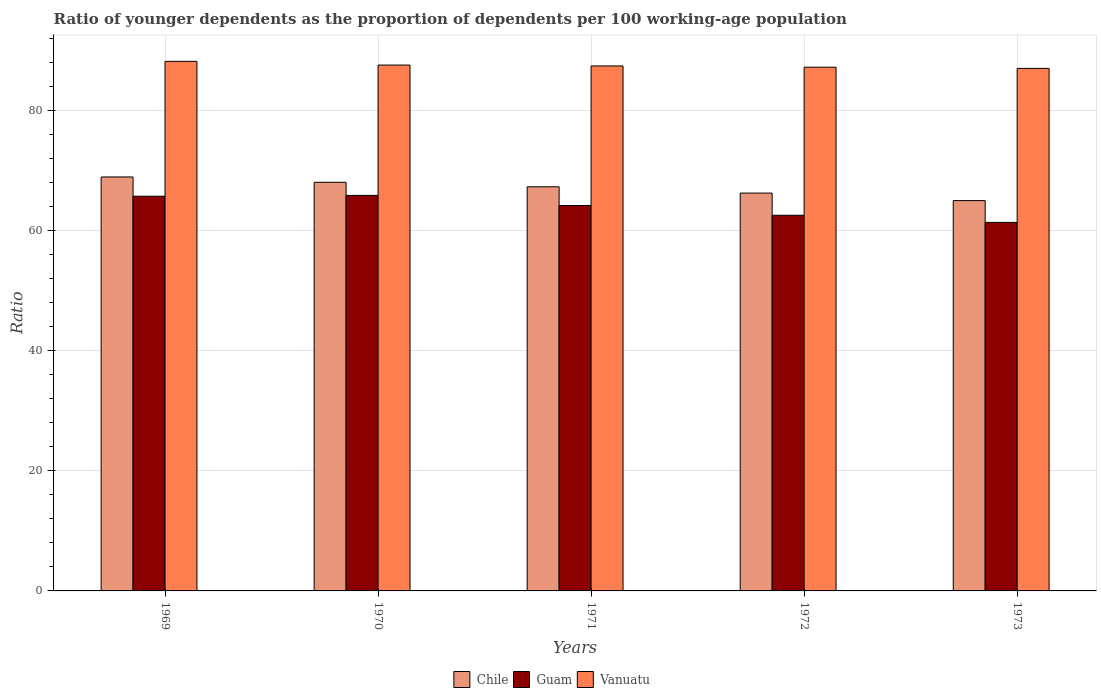How many groups of bars are there?
Ensure brevity in your answer.  5. How many bars are there on the 5th tick from the left?
Your response must be concise. 3. How many bars are there on the 2nd tick from the right?
Make the answer very short. 3. What is the label of the 2nd group of bars from the left?
Offer a terse response. 1970. In how many cases, is the number of bars for a given year not equal to the number of legend labels?
Provide a succinct answer. 0. What is the age dependency ratio(young) in Vanuatu in 1972?
Offer a terse response. 87.15. Across all years, what is the maximum age dependency ratio(young) in Guam?
Your answer should be compact. 65.81. Across all years, what is the minimum age dependency ratio(young) in Guam?
Provide a short and direct response. 61.32. In which year was the age dependency ratio(young) in Guam maximum?
Keep it short and to the point. 1970. What is the total age dependency ratio(young) in Guam in the graph?
Offer a very short reply. 319.45. What is the difference between the age dependency ratio(young) in Vanuatu in 1970 and that in 1972?
Offer a terse response. 0.35. What is the difference between the age dependency ratio(young) in Guam in 1969 and the age dependency ratio(young) in Vanuatu in 1972?
Ensure brevity in your answer.  -21.47. What is the average age dependency ratio(young) in Vanuatu per year?
Offer a terse response. 87.41. In the year 1973, what is the difference between the age dependency ratio(young) in Guam and age dependency ratio(young) in Chile?
Provide a short and direct response. -3.63. What is the ratio of the age dependency ratio(young) in Vanuatu in 1969 to that in 1972?
Keep it short and to the point. 1.01. Is the age dependency ratio(young) in Chile in 1970 less than that in 1972?
Offer a terse response. No. Is the difference between the age dependency ratio(young) in Guam in 1969 and 1971 greater than the difference between the age dependency ratio(young) in Chile in 1969 and 1971?
Provide a short and direct response. No. What is the difference between the highest and the second highest age dependency ratio(young) in Vanuatu?
Your answer should be very brief. 0.62. What is the difference between the highest and the lowest age dependency ratio(young) in Chile?
Offer a very short reply. 3.93. In how many years, is the age dependency ratio(young) in Vanuatu greater than the average age dependency ratio(young) in Vanuatu taken over all years?
Give a very brief answer. 2. Is the sum of the age dependency ratio(young) in Chile in 1970 and 1973 greater than the maximum age dependency ratio(young) in Vanuatu across all years?
Offer a terse response. Yes. What does the 3rd bar from the left in 1970 represents?
Your response must be concise. Vanuatu. What does the 1st bar from the right in 1971 represents?
Your response must be concise. Vanuatu. Is it the case that in every year, the sum of the age dependency ratio(young) in Chile and age dependency ratio(young) in Guam is greater than the age dependency ratio(young) in Vanuatu?
Offer a very short reply. Yes. How many bars are there?
Provide a succinct answer. 15. Are all the bars in the graph horizontal?
Your answer should be very brief. No. How many years are there in the graph?
Offer a terse response. 5. What is the difference between two consecutive major ticks on the Y-axis?
Your response must be concise. 20. Are the values on the major ticks of Y-axis written in scientific E-notation?
Keep it short and to the point. No. Does the graph contain any zero values?
Offer a very short reply. No. Where does the legend appear in the graph?
Ensure brevity in your answer.  Bottom center. How many legend labels are there?
Your answer should be compact. 3. How are the legend labels stacked?
Make the answer very short. Horizontal. What is the title of the graph?
Your response must be concise. Ratio of younger dependents as the proportion of dependents per 100 working-age population. Does "Guinea" appear as one of the legend labels in the graph?
Your response must be concise. No. What is the label or title of the X-axis?
Offer a terse response. Years. What is the label or title of the Y-axis?
Keep it short and to the point. Ratio. What is the Ratio of Chile in 1969?
Provide a short and direct response. 68.88. What is the Ratio of Guam in 1969?
Your response must be concise. 65.68. What is the Ratio of Vanuatu in 1969?
Make the answer very short. 88.12. What is the Ratio of Chile in 1970?
Your response must be concise. 67.99. What is the Ratio in Guam in 1970?
Provide a succinct answer. 65.81. What is the Ratio of Vanuatu in 1970?
Your response must be concise. 87.5. What is the Ratio of Chile in 1971?
Ensure brevity in your answer.  67.25. What is the Ratio of Guam in 1971?
Ensure brevity in your answer.  64.13. What is the Ratio in Vanuatu in 1971?
Your answer should be compact. 87.35. What is the Ratio of Chile in 1972?
Make the answer very short. 66.2. What is the Ratio of Guam in 1972?
Offer a very short reply. 62.51. What is the Ratio in Vanuatu in 1972?
Make the answer very short. 87.15. What is the Ratio of Chile in 1973?
Offer a terse response. 64.95. What is the Ratio of Guam in 1973?
Give a very brief answer. 61.32. What is the Ratio of Vanuatu in 1973?
Your response must be concise. 86.95. Across all years, what is the maximum Ratio of Chile?
Your answer should be very brief. 68.88. Across all years, what is the maximum Ratio of Guam?
Offer a very short reply. 65.81. Across all years, what is the maximum Ratio in Vanuatu?
Ensure brevity in your answer.  88.12. Across all years, what is the minimum Ratio of Chile?
Your answer should be compact. 64.95. Across all years, what is the minimum Ratio in Guam?
Provide a succinct answer. 61.32. Across all years, what is the minimum Ratio in Vanuatu?
Provide a short and direct response. 86.95. What is the total Ratio of Chile in the graph?
Provide a short and direct response. 335.26. What is the total Ratio in Guam in the graph?
Provide a short and direct response. 319.45. What is the total Ratio in Vanuatu in the graph?
Ensure brevity in your answer.  437.06. What is the difference between the Ratio in Chile in 1969 and that in 1970?
Keep it short and to the point. 0.89. What is the difference between the Ratio in Guam in 1969 and that in 1970?
Make the answer very short. -0.14. What is the difference between the Ratio in Vanuatu in 1969 and that in 1970?
Your response must be concise. 0.62. What is the difference between the Ratio of Chile in 1969 and that in 1971?
Offer a very short reply. 1.63. What is the difference between the Ratio of Guam in 1969 and that in 1971?
Keep it short and to the point. 1.55. What is the difference between the Ratio in Vanuatu in 1969 and that in 1971?
Ensure brevity in your answer.  0.76. What is the difference between the Ratio of Chile in 1969 and that in 1972?
Give a very brief answer. 2.68. What is the difference between the Ratio of Guam in 1969 and that in 1972?
Your answer should be compact. 3.17. What is the difference between the Ratio in Chile in 1969 and that in 1973?
Ensure brevity in your answer.  3.93. What is the difference between the Ratio in Guam in 1969 and that in 1973?
Your answer should be very brief. 4.36. What is the difference between the Ratio of Vanuatu in 1969 and that in 1973?
Your answer should be very brief. 1.17. What is the difference between the Ratio of Chile in 1970 and that in 1971?
Make the answer very short. 0.75. What is the difference between the Ratio of Guam in 1970 and that in 1971?
Offer a terse response. 1.68. What is the difference between the Ratio in Vanuatu in 1970 and that in 1971?
Provide a succinct answer. 0.14. What is the difference between the Ratio of Chile in 1970 and that in 1972?
Offer a terse response. 1.79. What is the difference between the Ratio in Guam in 1970 and that in 1972?
Provide a short and direct response. 3.31. What is the difference between the Ratio of Vanuatu in 1970 and that in 1972?
Offer a terse response. 0.35. What is the difference between the Ratio of Chile in 1970 and that in 1973?
Provide a short and direct response. 3.05. What is the difference between the Ratio in Guam in 1970 and that in 1973?
Provide a short and direct response. 4.5. What is the difference between the Ratio of Vanuatu in 1970 and that in 1973?
Provide a succinct answer. 0.55. What is the difference between the Ratio in Chile in 1971 and that in 1972?
Give a very brief answer. 1.05. What is the difference between the Ratio in Guam in 1971 and that in 1972?
Offer a terse response. 1.62. What is the difference between the Ratio in Vanuatu in 1971 and that in 1972?
Ensure brevity in your answer.  0.21. What is the difference between the Ratio in Chile in 1971 and that in 1973?
Your response must be concise. 2.3. What is the difference between the Ratio of Guam in 1971 and that in 1973?
Provide a succinct answer. 2.81. What is the difference between the Ratio of Vanuatu in 1971 and that in 1973?
Keep it short and to the point. 0.41. What is the difference between the Ratio in Chile in 1972 and that in 1973?
Your response must be concise. 1.25. What is the difference between the Ratio of Guam in 1972 and that in 1973?
Ensure brevity in your answer.  1.19. What is the difference between the Ratio of Vanuatu in 1972 and that in 1973?
Make the answer very short. 0.2. What is the difference between the Ratio of Chile in 1969 and the Ratio of Guam in 1970?
Provide a succinct answer. 3.07. What is the difference between the Ratio of Chile in 1969 and the Ratio of Vanuatu in 1970?
Provide a succinct answer. -18.62. What is the difference between the Ratio in Guam in 1969 and the Ratio in Vanuatu in 1970?
Provide a short and direct response. -21.82. What is the difference between the Ratio of Chile in 1969 and the Ratio of Guam in 1971?
Give a very brief answer. 4.75. What is the difference between the Ratio in Chile in 1969 and the Ratio in Vanuatu in 1971?
Your answer should be compact. -18.47. What is the difference between the Ratio of Guam in 1969 and the Ratio of Vanuatu in 1971?
Offer a very short reply. -21.68. What is the difference between the Ratio in Chile in 1969 and the Ratio in Guam in 1972?
Make the answer very short. 6.37. What is the difference between the Ratio in Chile in 1969 and the Ratio in Vanuatu in 1972?
Provide a short and direct response. -18.27. What is the difference between the Ratio of Guam in 1969 and the Ratio of Vanuatu in 1972?
Your response must be concise. -21.47. What is the difference between the Ratio in Chile in 1969 and the Ratio in Guam in 1973?
Offer a terse response. 7.56. What is the difference between the Ratio of Chile in 1969 and the Ratio of Vanuatu in 1973?
Make the answer very short. -18.07. What is the difference between the Ratio of Guam in 1969 and the Ratio of Vanuatu in 1973?
Offer a terse response. -21.27. What is the difference between the Ratio in Chile in 1970 and the Ratio in Guam in 1971?
Ensure brevity in your answer.  3.86. What is the difference between the Ratio in Chile in 1970 and the Ratio in Vanuatu in 1971?
Your answer should be compact. -19.36. What is the difference between the Ratio of Guam in 1970 and the Ratio of Vanuatu in 1971?
Make the answer very short. -21.54. What is the difference between the Ratio of Chile in 1970 and the Ratio of Guam in 1972?
Your answer should be compact. 5.48. What is the difference between the Ratio of Chile in 1970 and the Ratio of Vanuatu in 1972?
Provide a short and direct response. -19.15. What is the difference between the Ratio of Guam in 1970 and the Ratio of Vanuatu in 1972?
Provide a short and direct response. -21.33. What is the difference between the Ratio in Chile in 1970 and the Ratio in Guam in 1973?
Your answer should be compact. 6.67. What is the difference between the Ratio in Chile in 1970 and the Ratio in Vanuatu in 1973?
Make the answer very short. -18.95. What is the difference between the Ratio in Guam in 1970 and the Ratio in Vanuatu in 1973?
Make the answer very short. -21.13. What is the difference between the Ratio of Chile in 1971 and the Ratio of Guam in 1972?
Offer a terse response. 4.74. What is the difference between the Ratio in Chile in 1971 and the Ratio in Vanuatu in 1972?
Provide a succinct answer. -19.9. What is the difference between the Ratio of Guam in 1971 and the Ratio of Vanuatu in 1972?
Make the answer very short. -23.02. What is the difference between the Ratio in Chile in 1971 and the Ratio in Guam in 1973?
Provide a succinct answer. 5.93. What is the difference between the Ratio in Chile in 1971 and the Ratio in Vanuatu in 1973?
Provide a short and direct response. -19.7. What is the difference between the Ratio of Guam in 1971 and the Ratio of Vanuatu in 1973?
Offer a very short reply. -22.82. What is the difference between the Ratio of Chile in 1972 and the Ratio of Guam in 1973?
Provide a short and direct response. 4.88. What is the difference between the Ratio in Chile in 1972 and the Ratio in Vanuatu in 1973?
Make the answer very short. -20.75. What is the difference between the Ratio in Guam in 1972 and the Ratio in Vanuatu in 1973?
Ensure brevity in your answer.  -24.44. What is the average Ratio in Chile per year?
Keep it short and to the point. 67.05. What is the average Ratio in Guam per year?
Give a very brief answer. 63.89. What is the average Ratio of Vanuatu per year?
Give a very brief answer. 87.41. In the year 1969, what is the difference between the Ratio of Chile and Ratio of Guam?
Ensure brevity in your answer.  3.2. In the year 1969, what is the difference between the Ratio of Chile and Ratio of Vanuatu?
Your answer should be very brief. -19.24. In the year 1969, what is the difference between the Ratio of Guam and Ratio of Vanuatu?
Keep it short and to the point. -22.44. In the year 1970, what is the difference between the Ratio in Chile and Ratio in Guam?
Your response must be concise. 2.18. In the year 1970, what is the difference between the Ratio in Chile and Ratio in Vanuatu?
Ensure brevity in your answer.  -19.51. In the year 1970, what is the difference between the Ratio in Guam and Ratio in Vanuatu?
Ensure brevity in your answer.  -21.68. In the year 1971, what is the difference between the Ratio of Chile and Ratio of Guam?
Your answer should be very brief. 3.12. In the year 1971, what is the difference between the Ratio in Chile and Ratio in Vanuatu?
Your response must be concise. -20.11. In the year 1971, what is the difference between the Ratio in Guam and Ratio in Vanuatu?
Your answer should be compact. -23.22. In the year 1972, what is the difference between the Ratio of Chile and Ratio of Guam?
Offer a terse response. 3.69. In the year 1972, what is the difference between the Ratio in Chile and Ratio in Vanuatu?
Ensure brevity in your answer.  -20.95. In the year 1972, what is the difference between the Ratio in Guam and Ratio in Vanuatu?
Your answer should be compact. -24.64. In the year 1973, what is the difference between the Ratio in Chile and Ratio in Guam?
Ensure brevity in your answer.  3.63. In the year 1973, what is the difference between the Ratio in Chile and Ratio in Vanuatu?
Your answer should be very brief. -22. In the year 1973, what is the difference between the Ratio in Guam and Ratio in Vanuatu?
Your answer should be compact. -25.63. What is the ratio of the Ratio of Chile in 1969 to that in 1970?
Your answer should be very brief. 1.01. What is the ratio of the Ratio in Guam in 1969 to that in 1970?
Offer a very short reply. 1. What is the ratio of the Ratio in Vanuatu in 1969 to that in 1970?
Your answer should be compact. 1.01. What is the ratio of the Ratio in Chile in 1969 to that in 1971?
Offer a very short reply. 1.02. What is the ratio of the Ratio in Guam in 1969 to that in 1971?
Your answer should be compact. 1.02. What is the ratio of the Ratio of Vanuatu in 1969 to that in 1971?
Give a very brief answer. 1.01. What is the ratio of the Ratio of Chile in 1969 to that in 1972?
Make the answer very short. 1.04. What is the ratio of the Ratio in Guam in 1969 to that in 1972?
Offer a terse response. 1.05. What is the ratio of the Ratio in Vanuatu in 1969 to that in 1972?
Provide a succinct answer. 1.01. What is the ratio of the Ratio in Chile in 1969 to that in 1973?
Offer a terse response. 1.06. What is the ratio of the Ratio in Guam in 1969 to that in 1973?
Keep it short and to the point. 1.07. What is the ratio of the Ratio in Vanuatu in 1969 to that in 1973?
Keep it short and to the point. 1.01. What is the ratio of the Ratio of Chile in 1970 to that in 1971?
Offer a terse response. 1.01. What is the ratio of the Ratio in Guam in 1970 to that in 1971?
Make the answer very short. 1.03. What is the ratio of the Ratio in Chile in 1970 to that in 1972?
Provide a short and direct response. 1.03. What is the ratio of the Ratio in Guam in 1970 to that in 1972?
Provide a short and direct response. 1.05. What is the ratio of the Ratio in Vanuatu in 1970 to that in 1972?
Provide a succinct answer. 1. What is the ratio of the Ratio in Chile in 1970 to that in 1973?
Make the answer very short. 1.05. What is the ratio of the Ratio in Guam in 1970 to that in 1973?
Offer a terse response. 1.07. What is the ratio of the Ratio of Chile in 1971 to that in 1972?
Keep it short and to the point. 1.02. What is the ratio of the Ratio of Guam in 1971 to that in 1972?
Offer a terse response. 1.03. What is the ratio of the Ratio in Chile in 1971 to that in 1973?
Keep it short and to the point. 1.04. What is the ratio of the Ratio in Guam in 1971 to that in 1973?
Provide a succinct answer. 1.05. What is the ratio of the Ratio in Chile in 1972 to that in 1973?
Your answer should be very brief. 1.02. What is the ratio of the Ratio in Guam in 1972 to that in 1973?
Your answer should be very brief. 1.02. What is the ratio of the Ratio of Vanuatu in 1972 to that in 1973?
Offer a very short reply. 1. What is the difference between the highest and the second highest Ratio in Chile?
Your answer should be compact. 0.89. What is the difference between the highest and the second highest Ratio in Guam?
Your response must be concise. 0.14. What is the difference between the highest and the second highest Ratio of Vanuatu?
Give a very brief answer. 0.62. What is the difference between the highest and the lowest Ratio of Chile?
Give a very brief answer. 3.93. What is the difference between the highest and the lowest Ratio in Guam?
Provide a succinct answer. 4.5. What is the difference between the highest and the lowest Ratio of Vanuatu?
Ensure brevity in your answer.  1.17. 